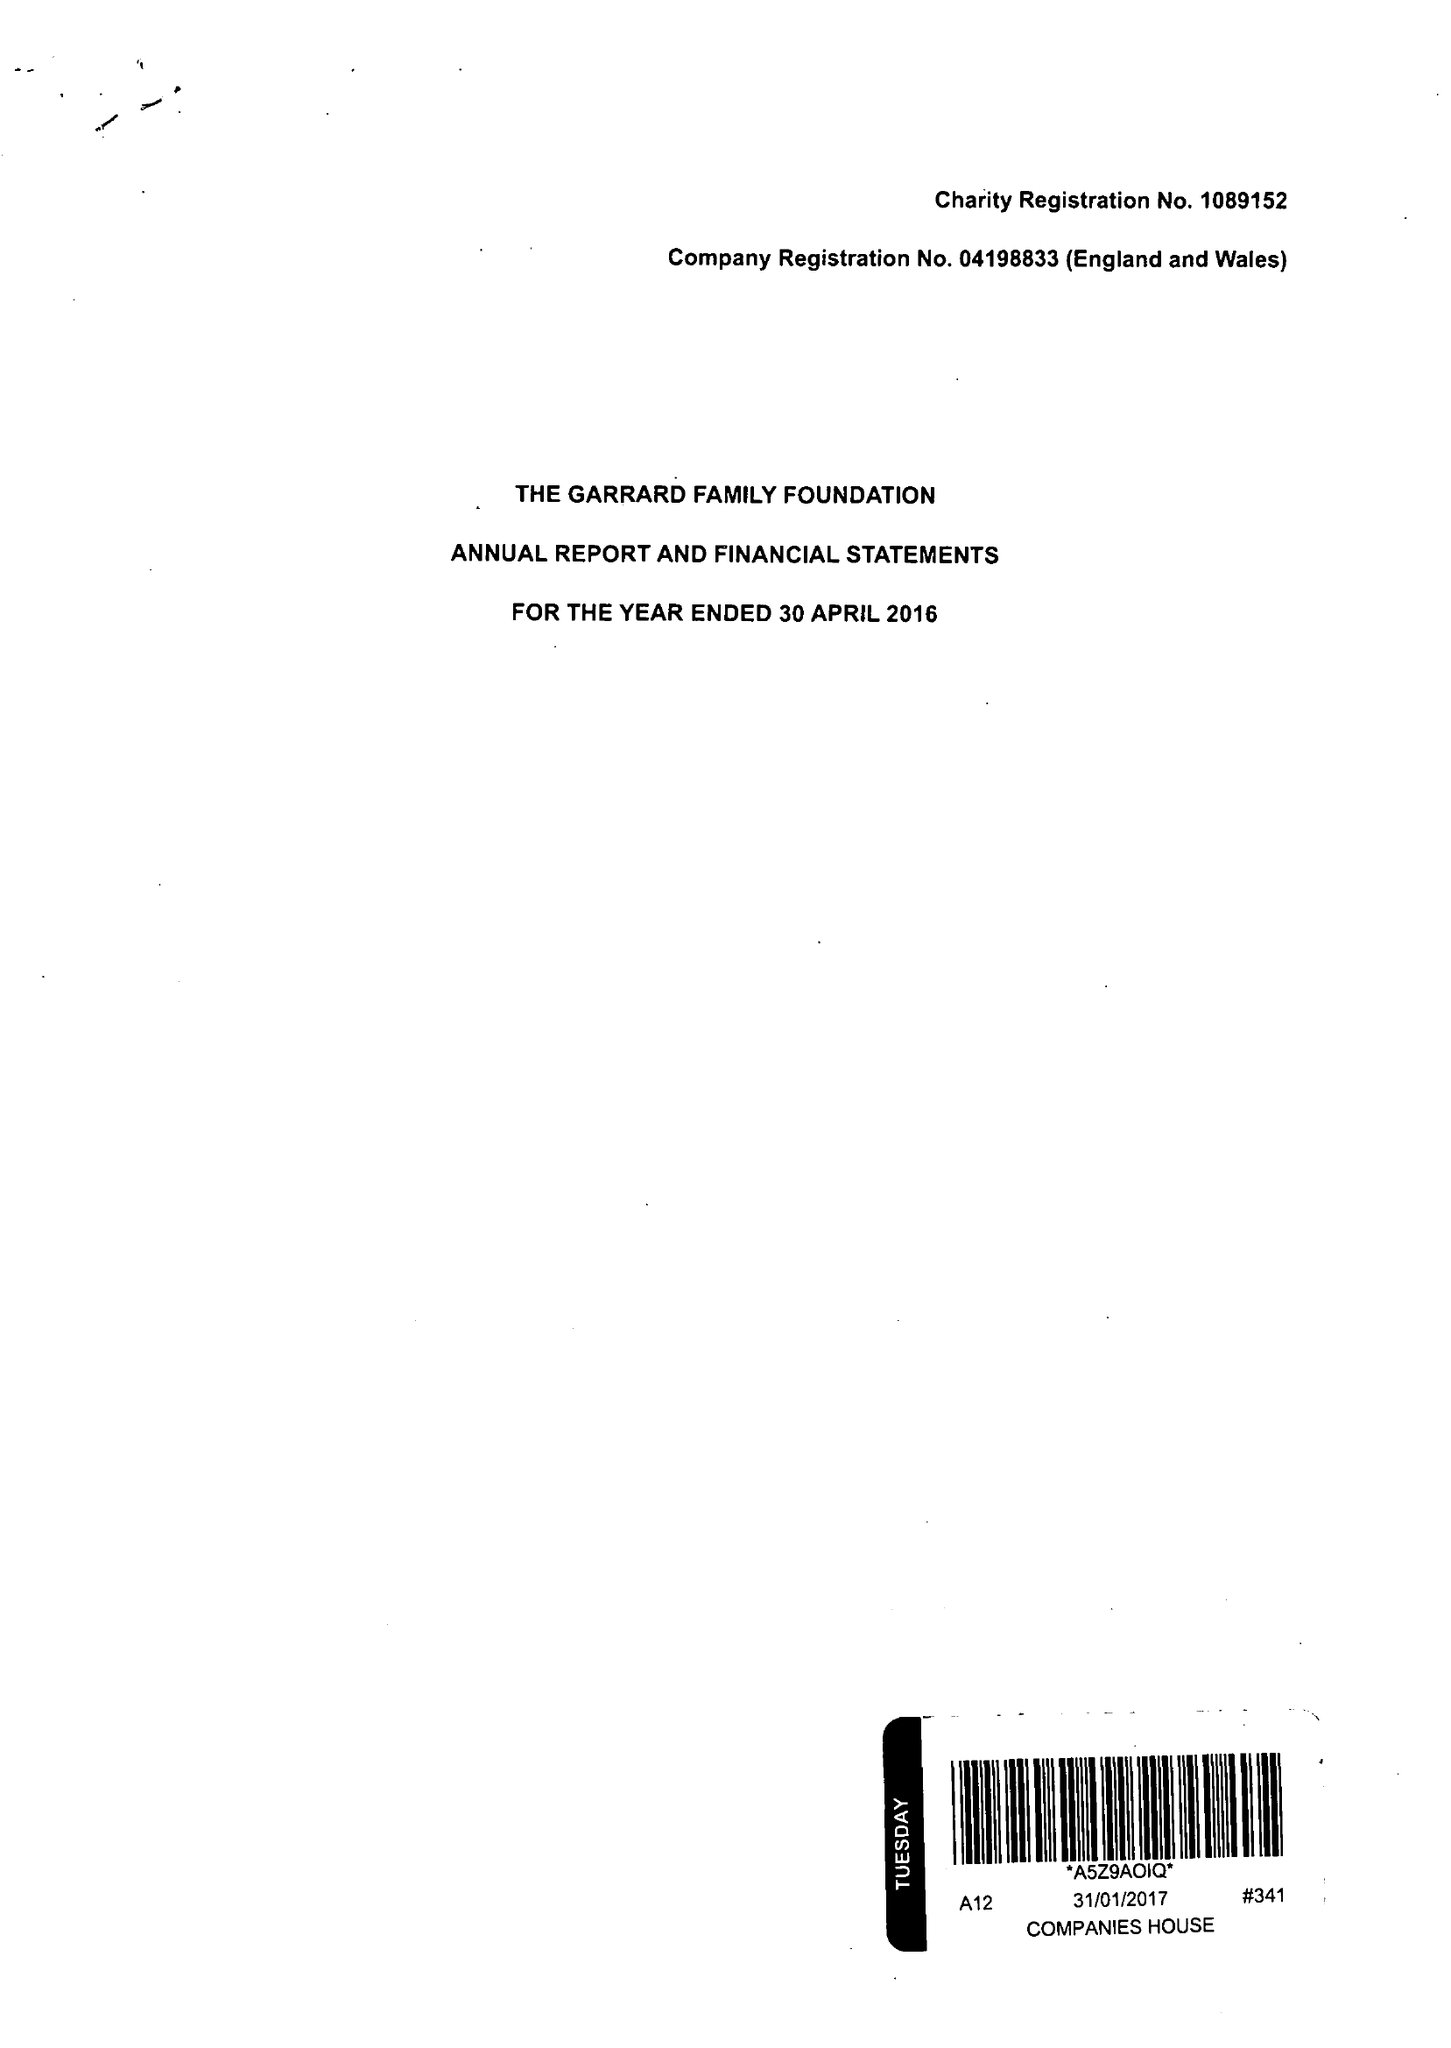What is the value for the charity_number?
Answer the question using a single word or phrase. 1089152 